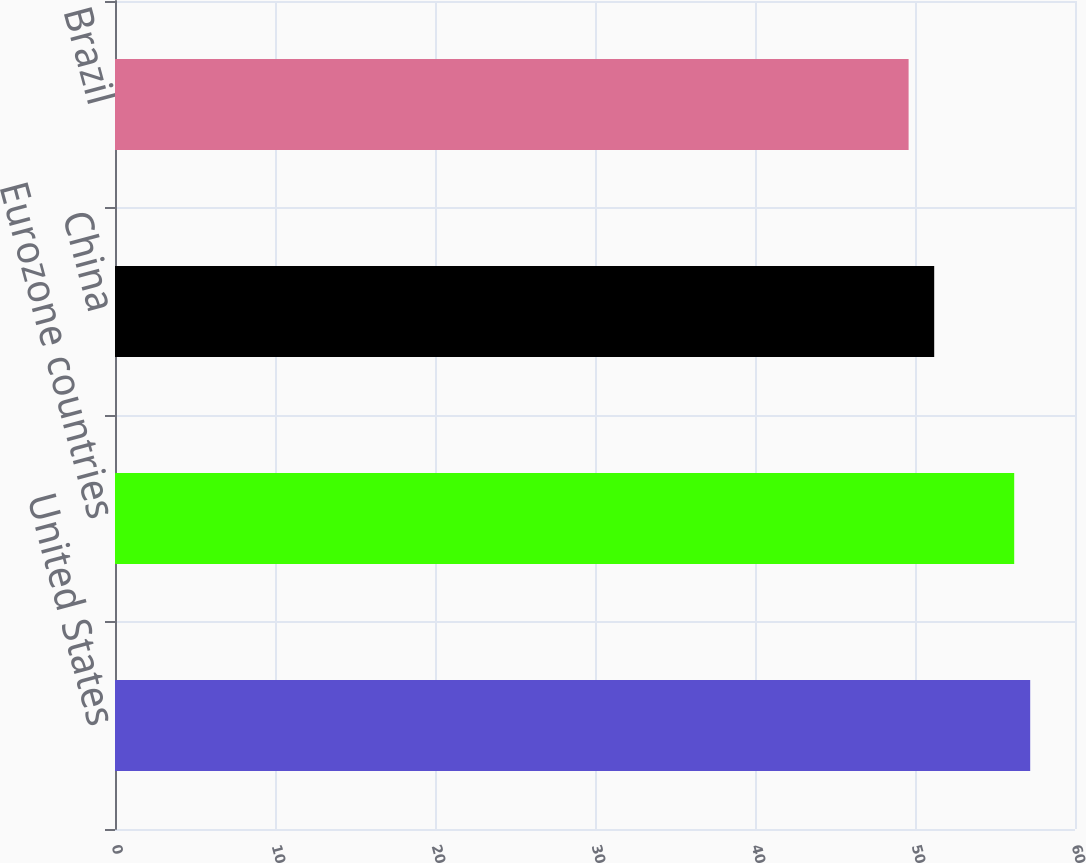Convert chart. <chart><loc_0><loc_0><loc_500><loc_500><bar_chart><fcel>United States<fcel>Eurozone countries<fcel>China<fcel>Brazil<nl><fcel>57.2<fcel>56.2<fcel>51.2<fcel>49.6<nl></chart> 